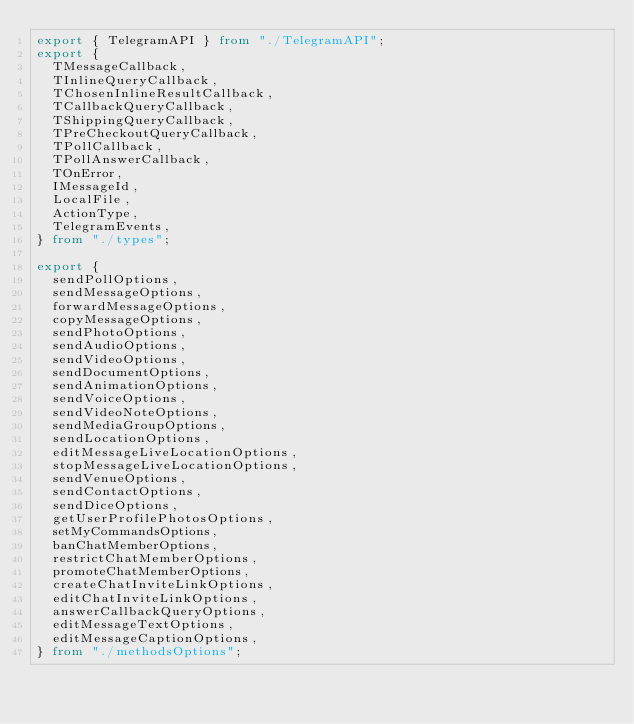<code> <loc_0><loc_0><loc_500><loc_500><_TypeScript_>export { TelegramAPI } from "./TelegramAPI";
export {
  TMessageCallback,
  TInlineQueryCallback,
  TChosenInlineResultCallback,
  TCallbackQueryCallback,
  TShippingQueryCallback,
  TPreCheckoutQueryCallback,
  TPollCallback,
  TPollAnswerCallback,
  TOnError,
  IMessageId,
  LocalFile,
  ActionType,
  TelegramEvents,
} from "./types";

export {
  sendPollOptions,
  sendMessageOptions,
  forwardMessageOptions,
  copyMessageOptions,
  sendPhotoOptions,
  sendAudioOptions,
  sendVideoOptions,
  sendDocumentOptions,
  sendAnimationOptions,
  sendVoiceOptions,
  sendVideoNoteOptions,
  sendMediaGroupOptions,
  sendLocationOptions,
  editMessageLiveLocationOptions,
  stopMessageLiveLocationOptions,
  sendVenueOptions,
  sendContactOptions,
  sendDiceOptions,
  getUserProfilePhotosOptions,
  setMyCommandsOptions,
  banChatMemberOptions,
  restrictChatMemberOptions,
  promoteChatMemberOptions,
  createChatInviteLinkOptions,
  editChatInviteLinkOptions,
  answerCallbackQueryOptions,
  editMessageTextOptions,
  editMessageCaptionOptions,
} from "./methodsOptions";
</code> 